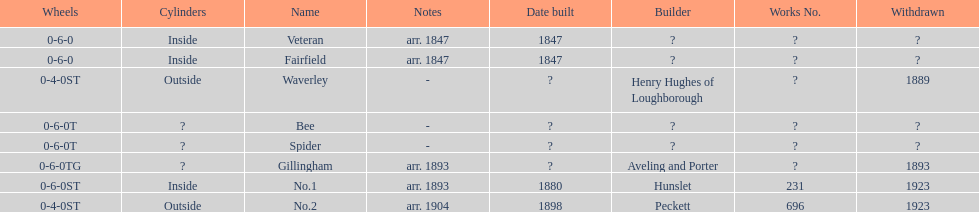Were there more with inside or outside cylinders? Inside. 